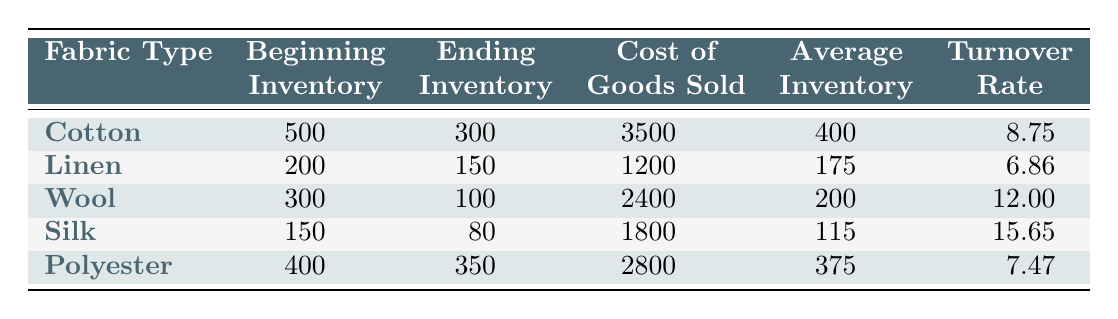What is the turnover rate for Silk? The turnover rate for Silk is provided directly in the table under the "Turnover Rate" column. For Silk, this number is 15.65.
Answer: 15.65 What was the beginning inventory of Cotton? The beginning inventory for Cotton can be found in the "Beginning Inventory" column in the table. It shows that the beginning inventory for Cotton was 500.
Answer: 500 Which fabric type has the highest turnover rate? To find this, I will look at the "Turnover Rate" column and identify the highest value. The highest turnover rate is for Silk at 15.65.
Answer: Silk Is the ending inventory of Polyester greater than that of Linen? I will compare the "Ending Inventory" figures for both Polyester (350) and Linen (150). Since 350 is greater than 150, the statement is true.
Answer: Yes What is the average inventory for Wool? The average inventory for Wool is mentioned in the "Average Inventory" column specifically for Wool. The value is 200.
Answer: 200 What is the total cost of goods sold for all fabric types? I will sum up the "Cost of Goods Sold" values from each fabric type: 3500 (Cotton) + 1200 (Linen) + 2400 (Wool) + 1800 (Silk) + 2800 (Polyester) = 11700. The total is 11700.
Answer: 11700 If the average turnover rate for all fabrics is calculated, will it be greater than 10? I will compute the average of the turnover rates: (8.75 + 6.86 + 12.00 + 15.65 + 7.47) / 5 = 10.166. Since 10.166 is greater than 10, the statement is true.
Answer: Yes What is the difference in turnover rates between Wool and Polyester? The turnover rate for Wool is 12.00 and for Polyester, it's 7.47. The difference is calculated as 12.00 - 7.47 = 4.53.
Answer: 4.53 Does any fabric type have a turnover rate lower than 7? I will check the turnover rates for all fabrics: Cotton (8.75), Linen (6.86), Wool (12.00), Silk (15.65), and Polyester (7.47). Since Linen has a turnover rate of 6.86, which is lower than 7, the answer is yes.
Answer: Yes 